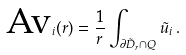Convert formula to latex. <formula><loc_0><loc_0><loc_500><loc_500>\text {Av} _ { i } ( r ) = \frac { 1 } { r } \int _ { \partial \tilde { D } _ { r } \cap Q } \tilde { u } _ { i } \, .</formula> 